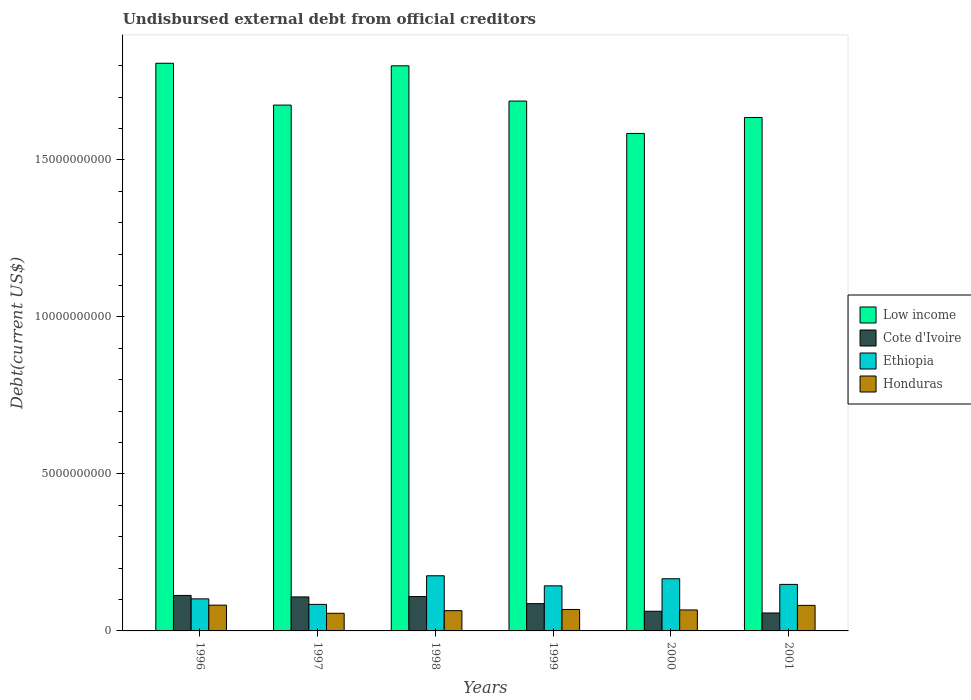How many bars are there on the 2nd tick from the left?
Make the answer very short. 4. How many bars are there on the 2nd tick from the right?
Your response must be concise. 4. What is the label of the 4th group of bars from the left?
Keep it short and to the point. 1999. In how many cases, is the number of bars for a given year not equal to the number of legend labels?
Offer a very short reply. 0. What is the total debt in Ethiopia in 1997?
Your response must be concise. 8.45e+08. Across all years, what is the maximum total debt in Honduras?
Give a very brief answer. 8.21e+08. Across all years, what is the minimum total debt in Cote d'Ivoire?
Give a very brief answer. 5.71e+08. In which year was the total debt in Cote d'Ivoire maximum?
Your answer should be compact. 1996. What is the total total debt in Ethiopia in the graph?
Ensure brevity in your answer.  8.20e+09. What is the difference between the total debt in Ethiopia in 2000 and that in 2001?
Your answer should be compact. 1.80e+08. What is the difference between the total debt in Honduras in 2001 and the total debt in Low income in 1996?
Provide a short and direct response. -1.73e+1. What is the average total debt in Ethiopia per year?
Provide a short and direct response. 1.37e+09. In the year 1999, what is the difference between the total debt in Honduras and total debt in Cote d'Ivoire?
Make the answer very short. -1.86e+08. What is the ratio of the total debt in Low income in 1998 to that in 2001?
Offer a very short reply. 1.1. Is the difference between the total debt in Honduras in 1997 and 1998 greater than the difference between the total debt in Cote d'Ivoire in 1997 and 1998?
Make the answer very short. No. What is the difference between the highest and the second highest total debt in Honduras?
Your answer should be very brief. 6.82e+06. What is the difference between the highest and the lowest total debt in Honduras?
Offer a terse response. 2.59e+08. Is the sum of the total debt in Ethiopia in 1996 and 1999 greater than the maximum total debt in Low income across all years?
Provide a succinct answer. No. What does the 2nd bar from the left in 1997 represents?
Make the answer very short. Cote d'Ivoire. What does the 4th bar from the right in 2001 represents?
Offer a terse response. Low income. Are the values on the major ticks of Y-axis written in scientific E-notation?
Offer a terse response. No. Does the graph contain grids?
Your response must be concise. No. What is the title of the graph?
Offer a very short reply. Undisbursed external debt from official creditors. What is the label or title of the Y-axis?
Give a very brief answer. Debt(current US$). What is the Debt(current US$) in Low income in 1996?
Your response must be concise. 1.81e+1. What is the Debt(current US$) of Cote d'Ivoire in 1996?
Provide a short and direct response. 1.13e+09. What is the Debt(current US$) in Ethiopia in 1996?
Give a very brief answer. 1.02e+09. What is the Debt(current US$) in Honduras in 1996?
Your answer should be very brief. 8.21e+08. What is the Debt(current US$) in Low income in 1997?
Offer a very short reply. 1.67e+1. What is the Debt(current US$) in Cote d'Ivoire in 1997?
Ensure brevity in your answer.  1.08e+09. What is the Debt(current US$) in Ethiopia in 1997?
Keep it short and to the point. 8.45e+08. What is the Debt(current US$) of Honduras in 1997?
Give a very brief answer. 5.62e+08. What is the Debt(current US$) in Low income in 1998?
Offer a terse response. 1.80e+1. What is the Debt(current US$) of Cote d'Ivoire in 1998?
Offer a very short reply. 1.09e+09. What is the Debt(current US$) in Ethiopia in 1998?
Keep it short and to the point. 1.76e+09. What is the Debt(current US$) of Honduras in 1998?
Your response must be concise. 6.46e+08. What is the Debt(current US$) in Low income in 1999?
Ensure brevity in your answer.  1.69e+1. What is the Debt(current US$) in Cote d'Ivoire in 1999?
Ensure brevity in your answer.  8.69e+08. What is the Debt(current US$) in Ethiopia in 1999?
Provide a short and direct response. 1.44e+09. What is the Debt(current US$) in Honduras in 1999?
Make the answer very short. 6.83e+08. What is the Debt(current US$) in Low income in 2000?
Make the answer very short. 1.58e+1. What is the Debt(current US$) of Cote d'Ivoire in 2000?
Your answer should be very brief. 6.26e+08. What is the Debt(current US$) of Ethiopia in 2000?
Offer a terse response. 1.66e+09. What is the Debt(current US$) of Honduras in 2000?
Your answer should be compact. 6.68e+08. What is the Debt(current US$) in Low income in 2001?
Your answer should be compact. 1.64e+1. What is the Debt(current US$) in Cote d'Ivoire in 2001?
Your answer should be compact. 5.71e+08. What is the Debt(current US$) in Ethiopia in 2001?
Your response must be concise. 1.48e+09. What is the Debt(current US$) in Honduras in 2001?
Make the answer very short. 8.14e+08. Across all years, what is the maximum Debt(current US$) in Low income?
Provide a succinct answer. 1.81e+1. Across all years, what is the maximum Debt(current US$) of Cote d'Ivoire?
Your answer should be very brief. 1.13e+09. Across all years, what is the maximum Debt(current US$) of Ethiopia?
Your response must be concise. 1.76e+09. Across all years, what is the maximum Debt(current US$) in Honduras?
Provide a short and direct response. 8.21e+08. Across all years, what is the minimum Debt(current US$) of Low income?
Make the answer very short. 1.58e+1. Across all years, what is the minimum Debt(current US$) in Cote d'Ivoire?
Offer a very short reply. 5.71e+08. Across all years, what is the minimum Debt(current US$) in Ethiopia?
Offer a terse response. 8.45e+08. Across all years, what is the minimum Debt(current US$) of Honduras?
Keep it short and to the point. 5.62e+08. What is the total Debt(current US$) in Low income in the graph?
Make the answer very short. 1.02e+11. What is the total Debt(current US$) in Cote d'Ivoire in the graph?
Provide a short and direct response. 5.37e+09. What is the total Debt(current US$) of Ethiopia in the graph?
Keep it short and to the point. 8.20e+09. What is the total Debt(current US$) of Honduras in the graph?
Provide a succinct answer. 4.19e+09. What is the difference between the Debt(current US$) of Low income in 1996 and that in 1997?
Provide a short and direct response. 1.33e+09. What is the difference between the Debt(current US$) of Cote d'Ivoire in 1996 and that in 1997?
Your answer should be very brief. 4.72e+07. What is the difference between the Debt(current US$) of Ethiopia in 1996 and that in 1997?
Your answer should be very brief. 1.76e+08. What is the difference between the Debt(current US$) in Honduras in 1996 and that in 1997?
Provide a succinct answer. 2.59e+08. What is the difference between the Debt(current US$) in Low income in 1996 and that in 1998?
Give a very brief answer. 8.14e+07. What is the difference between the Debt(current US$) in Cote d'Ivoire in 1996 and that in 1998?
Your answer should be very brief. 3.64e+07. What is the difference between the Debt(current US$) of Ethiopia in 1996 and that in 1998?
Make the answer very short. -7.36e+08. What is the difference between the Debt(current US$) in Honduras in 1996 and that in 1998?
Your answer should be compact. 1.75e+08. What is the difference between the Debt(current US$) of Low income in 1996 and that in 1999?
Provide a short and direct response. 1.20e+09. What is the difference between the Debt(current US$) in Cote d'Ivoire in 1996 and that in 1999?
Your answer should be very brief. 2.61e+08. What is the difference between the Debt(current US$) in Ethiopia in 1996 and that in 1999?
Ensure brevity in your answer.  -4.15e+08. What is the difference between the Debt(current US$) of Honduras in 1996 and that in 1999?
Offer a very short reply. 1.38e+08. What is the difference between the Debt(current US$) in Low income in 1996 and that in 2000?
Provide a succinct answer. 2.24e+09. What is the difference between the Debt(current US$) in Cote d'Ivoire in 1996 and that in 2000?
Keep it short and to the point. 5.04e+08. What is the difference between the Debt(current US$) in Ethiopia in 1996 and that in 2000?
Your answer should be very brief. -6.41e+08. What is the difference between the Debt(current US$) in Honduras in 1996 and that in 2000?
Provide a succinct answer. 1.53e+08. What is the difference between the Debt(current US$) of Low income in 1996 and that in 2001?
Your answer should be compact. 1.73e+09. What is the difference between the Debt(current US$) of Cote d'Ivoire in 1996 and that in 2001?
Provide a succinct answer. 5.59e+08. What is the difference between the Debt(current US$) of Ethiopia in 1996 and that in 2001?
Provide a short and direct response. -4.61e+08. What is the difference between the Debt(current US$) of Honduras in 1996 and that in 2001?
Your answer should be compact. 6.82e+06. What is the difference between the Debt(current US$) in Low income in 1997 and that in 1998?
Keep it short and to the point. -1.25e+09. What is the difference between the Debt(current US$) in Cote d'Ivoire in 1997 and that in 1998?
Give a very brief answer. -1.08e+07. What is the difference between the Debt(current US$) of Ethiopia in 1997 and that in 1998?
Give a very brief answer. -9.11e+08. What is the difference between the Debt(current US$) of Honduras in 1997 and that in 1998?
Offer a terse response. -8.40e+07. What is the difference between the Debt(current US$) of Low income in 1997 and that in 1999?
Provide a succinct answer. -1.28e+08. What is the difference between the Debt(current US$) in Cote d'Ivoire in 1997 and that in 1999?
Your answer should be very brief. 2.14e+08. What is the difference between the Debt(current US$) in Ethiopia in 1997 and that in 1999?
Ensure brevity in your answer.  -5.91e+08. What is the difference between the Debt(current US$) in Honduras in 1997 and that in 1999?
Ensure brevity in your answer.  -1.22e+08. What is the difference between the Debt(current US$) of Low income in 1997 and that in 2000?
Your answer should be compact. 9.03e+08. What is the difference between the Debt(current US$) of Cote d'Ivoire in 1997 and that in 2000?
Provide a short and direct response. 4.57e+08. What is the difference between the Debt(current US$) of Ethiopia in 1997 and that in 2000?
Provide a succinct answer. -8.17e+08. What is the difference between the Debt(current US$) in Honduras in 1997 and that in 2000?
Give a very brief answer. -1.06e+08. What is the difference between the Debt(current US$) of Low income in 1997 and that in 2001?
Your response must be concise. 3.95e+08. What is the difference between the Debt(current US$) of Cote d'Ivoire in 1997 and that in 2001?
Provide a succinct answer. 5.12e+08. What is the difference between the Debt(current US$) in Ethiopia in 1997 and that in 2001?
Your response must be concise. -6.37e+08. What is the difference between the Debt(current US$) of Honduras in 1997 and that in 2001?
Provide a short and direct response. -2.52e+08. What is the difference between the Debt(current US$) in Low income in 1998 and that in 1999?
Your answer should be very brief. 1.12e+09. What is the difference between the Debt(current US$) in Cote d'Ivoire in 1998 and that in 1999?
Your answer should be very brief. 2.25e+08. What is the difference between the Debt(current US$) of Ethiopia in 1998 and that in 1999?
Provide a short and direct response. 3.21e+08. What is the difference between the Debt(current US$) of Honduras in 1998 and that in 1999?
Offer a terse response. -3.75e+07. What is the difference between the Debt(current US$) in Low income in 1998 and that in 2000?
Ensure brevity in your answer.  2.15e+09. What is the difference between the Debt(current US$) of Cote d'Ivoire in 1998 and that in 2000?
Provide a short and direct response. 4.68e+08. What is the difference between the Debt(current US$) in Ethiopia in 1998 and that in 2000?
Make the answer very short. 9.50e+07. What is the difference between the Debt(current US$) of Honduras in 1998 and that in 2000?
Make the answer very short. -2.24e+07. What is the difference between the Debt(current US$) in Low income in 1998 and that in 2001?
Your answer should be compact. 1.65e+09. What is the difference between the Debt(current US$) in Cote d'Ivoire in 1998 and that in 2001?
Offer a very short reply. 5.22e+08. What is the difference between the Debt(current US$) in Ethiopia in 1998 and that in 2001?
Make the answer very short. 2.75e+08. What is the difference between the Debt(current US$) in Honduras in 1998 and that in 2001?
Give a very brief answer. -1.68e+08. What is the difference between the Debt(current US$) of Low income in 1999 and that in 2000?
Make the answer very short. 1.03e+09. What is the difference between the Debt(current US$) in Cote d'Ivoire in 1999 and that in 2000?
Keep it short and to the point. 2.43e+08. What is the difference between the Debt(current US$) in Ethiopia in 1999 and that in 2000?
Offer a very short reply. -2.26e+08. What is the difference between the Debt(current US$) in Honduras in 1999 and that in 2000?
Ensure brevity in your answer.  1.51e+07. What is the difference between the Debt(current US$) of Low income in 1999 and that in 2001?
Provide a short and direct response. 5.23e+08. What is the difference between the Debt(current US$) of Cote d'Ivoire in 1999 and that in 2001?
Your answer should be compact. 2.97e+08. What is the difference between the Debt(current US$) in Ethiopia in 1999 and that in 2001?
Give a very brief answer. -4.62e+07. What is the difference between the Debt(current US$) in Honduras in 1999 and that in 2001?
Ensure brevity in your answer.  -1.31e+08. What is the difference between the Debt(current US$) of Low income in 2000 and that in 2001?
Ensure brevity in your answer.  -5.08e+08. What is the difference between the Debt(current US$) in Cote d'Ivoire in 2000 and that in 2001?
Your answer should be compact. 5.46e+07. What is the difference between the Debt(current US$) in Ethiopia in 2000 and that in 2001?
Provide a short and direct response. 1.80e+08. What is the difference between the Debt(current US$) in Honduras in 2000 and that in 2001?
Offer a very short reply. -1.46e+08. What is the difference between the Debt(current US$) of Low income in 1996 and the Debt(current US$) of Cote d'Ivoire in 1997?
Offer a very short reply. 1.70e+1. What is the difference between the Debt(current US$) in Low income in 1996 and the Debt(current US$) in Ethiopia in 1997?
Your answer should be compact. 1.72e+1. What is the difference between the Debt(current US$) in Low income in 1996 and the Debt(current US$) in Honduras in 1997?
Offer a very short reply. 1.75e+1. What is the difference between the Debt(current US$) in Cote d'Ivoire in 1996 and the Debt(current US$) in Ethiopia in 1997?
Your answer should be compact. 2.85e+08. What is the difference between the Debt(current US$) of Cote d'Ivoire in 1996 and the Debt(current US$) of Honduras in 1997?
Your answer should be compact. 5.69e+08. What is the difference between the Debt(current US$) of Ethiopia in 1996 and the Debt(current US$) of Honduras in 1997?
Provide a succinct answer. 4.59e+08. What is the difference between the Debt(current US$) of Low income in 1996 and the Debt(current US$) of Cote d'Ivoire in 1998?
Offer a terse response. 1.70e+1. What is the difference between the Debt(current US$) of Low income in 1996 and the Debt(current US$) of Ethiopia in 1998?
Keep it short and to the point. 1.63e+1. What is the difference between the Debt(current US$) in Low income in 1996 and the Debt(current US$) in Honduras in 1998?
Ensure brevity in your answer.  1.74e+1. What is the difference between the Debt(current US$) of Cote d'Ivoire in 1996 and the Debt(current US$) of Ethiopia in 1998?
Your response must be concise. -6.26e+08. What is the difference between the Debt(current US$) in Cote d'Ivoire in 1996 and the Debt(current US$) in Honduras in 1998?
Your answer should be compact. 4.84e+08. What is the difference between the Debt(current US$) in Ethiopia in 1996 and the Debt(current US$) in Honduras in 1998?
Ensure brevity in your answer.  3.75e+08. What is the difference between the Debt(current US$) of Low income in 1996 and the Debt(current US$) of Cote d'Ivoire in 1999?
Give a very brief answer. 1.72e+1. What is the difference between the Debt(current US$) in Low income in 1996 and the Debt(current US$) in Ethiopia in 1999?
Keep it short and to the point. 1.66e+1. What is the difference between the Debt(current US$) of Low income in 1996 and the Debt(current US$) of Honduras in 1999?
Offer a terse response. 1.74e+1. What is the difference between the Debt(current US$) in Cote d'Ivoire in 1996 and the Debt(current US$) in Ethiopia in 1999?
Offer a terse response. -3.06e+08. What is the difference between the Debt(current US$) in Cote d'Ivoire in 1996 and the Debt(current US$) in Honduras in 1999?
Make the answer very short. 4.47e+08. What is the difference between the Debt(current US$) in Ethiopia in 1996 and the Debt(current US$) in Honduras in 1999?
Ensure brevity in your answer.  3.38e+08. What is the difference between the Debt(current US$) in Low income in 1996 and the Debt(current US$) in Cote d'Ivoire in 2000?
Provide a short and direct response. 1.75e+1. What is the difference between the Debt(current US$) in Low income in 1996 and the Debt(current US$) in Ethiopia in 2000?
Your response must be concise. 1.64e+1. What is the difference between the Debt(current US$) in Low income in 1996 and the Debt(current US$) in Honduras in 2000?
Provide a short and direct response. 1.74e+1. What is the difference between the Debt(current US$) of Cote d'Ivoire in 1996 and the Debt(current US$) of Ethiopia in 2000?
Provide a succinct answer. -5.31e+08. What is the difference between the Debt(current US$) of Cote d'Ivoire in 1996 and the Debt(current US$) of Honduras in 2000?
Provide a succinct answer. 4.62e+08. What is the difference between the Debt(current US$) in Ethiopia in 1996 and the Debt(current US$) in Honduras in 2000?
Provide a short and direct response. 3.53e+08. What is the difference between the Debt(current US$) in Low income in 1996 and the Debt(current US$) in Cote d'Ivoire in 2001?
Your answer should be compact. 1.75e+1. What is the difference between the Debt(current US$) of Low income in 1996 and the Debt(current US$) of Ethiopia in 2001?
Ensure brevity in your answer.  1.66e+1. What is the difference between the Debt(current US$) in Low income in 1996 and the Debt(current US$) in Honduras in 2001?
Offer a terse response. 1.73e+1. What is the difference between the Debt(current US$) of Cote d'Ivoire in 1996 and the Debt(current US$) of Ethiopia in 2001?
Your answer should be very brief. -3.52e+08. What is the difference between the Debt(current US$) of Cote d'Ivoire in 1996 and the Debt(current US$) of Honduras in 2001?
Offer a terse response. 3.16e+08. What is the difference between the Debt(current US$) of Ethiopia in 1996 and the Debt(current US$) of Honduras in 2001?
Ensure brevity in your answer.  2.07e+08. What is the difference between the Debt(current US$) of Low income in 1997 and the Debt(current US$) of Cote d'Ivoire in 1998?
Your answer should be compact. 1.57e+1. What is the difference between the Debt(current US$) in Low income in 1997 and the Debt(current US$) in Ethiopia in 1998?
Your answer should be very brief. 1.50e+1. What is the difference between the Debt(current US$) of Low income in 1997 and the Debt(current US$) of Honduras in 1998?
Offer a very short reply. 1.61e+1. What is the difference between the Debt(current US$) in Cote d'Ivoire in 1997 and the Debt(current US$) in Ethiopia in 1998?
Provide a short and direct response. -6.74e+08. What is the difference between the Debt(current US$) of Cote d'Ivoire in 1997 and the Debt(current US$) of Honduras in 1998?
Give a very brief answer. 4.37e+08. What is the difference between the Debt(current US$) in Ethiopia in 1997 and the Debt(current US$) in Honduras in 1998?
Your answer should be compact. 1.99e+08. What is the difference between the Debt(current US$) of Low income in 1997 and the Debt(current US$) of Cote d'Ivoire in 1999?
Ensure brevity in your answer.  1.59e+1. What is the difference between the Debt(current US$) in Low income in 1997 and the Debt(current US$) in Ethiopia in 1999?
Your answer should be compact. 1.53e+1. What is the difference between the Debt(current US$) in Low income in 1997 and the Debt(current US$) in Honduras in 1999?
Your answer should be very brief. 1.61e+1. What is the difference between the Debt(current US$) of Cote d'Ivoire in 1997 and the Debt(current US$) of Ethiopia in 1999?
Provide a short and direct response. -3.53e+08. What is the difference between the Debt(current US$) of Cote d'Ivoire in 1997 and the Debt(current US$) of Honduras in 1999?
Give a very brief answer. 4.00e+08. What is the difference between the Debt(current US$) of Ethiopia in 1997 and the Debt(current US$) of Honduras in 1999?
Your answer should be compact. 1.62e+08. What is the difference between the Debt(current US$) in Low income in 1997 and the Debt(current US$) in Cote d'Ivoire in 2000?
Your answer should be compact. 1.61e+1. What is the difference between the Debt(current US$) of Low income in 1997 and the Debt(current US$) of Ethiopia in 2000?
Provide a succinct answer. 1.51e+1. What is the difference between the Debt(current US$) of Low income in 1997 and the Debt(current US$) of Honduras in 2000?
Make the answer very short. 1.61e+1. What is the difference between the Debt(current US$) of Cote d'Ivoire in 1997 and the Debt(current US$) of Ethiopia in 2000?
Give a very brief answer. -5.79e+08. What is the difference between the Debt(current US$) of Cote d'Ivoire in 1997 and the Debt(current US$) of Honduras in 2000?
Offer a terse response. 4.15e+08. What is the difference between the Debt(current US$) in Ethiopia in 1997 and the Debt(current US$) in Honduras in 2000?
Provide a short and direct response. 1.77e+08. What is the difference between the Debt(current US$) of Low income in 1997 and the Debt(current US$) of Cote d'Ivoire in 2001?
Ensure brevity in your answer.  1.62e+1. What is the difference between the Debt(current US$) of Low income in 1997 and the Debt(current US$) of Ethiopia in 2001?
Provide a succinct answer. 1.53e+1. What is the difference between the Debt(current US$) of Low income in 1997 and the Debt(current US$) of Honduras in 2001?
Your response must be concise. 1.59e+1. What is the difference between the Debt(current US$) in Cote d'Ivoire in 1997 and the Debt(current US$) in Ethiopia in 2001?
Provide a short and direct response. -3.99e+08. What is the difference between the Debt(current US$) of Cote d'Ivoire in 1997 and the Debt(current US$) of Honduras in 2001?
Make the answer very short. 2.69e+08. What is the difference between the Debt(current US$) in Ethiopia in 1997 and the Debt(current US$) in Honduras in 2001?
Your response must be concise. 3.10e+07. What is the difference between the Debt(current US$) in Low income in 1998 and the Debt(current US$) in Cote d'Ivoire in 1999?
Provide a short and direct response. 1.71e+1. What is the difference between the Debt(current US$) in Low income in 1998 and the Debt(current US$) in Ethiopia in 1999?
Ensure brevity in your answer.  1.66e+1. What is the difference between the Debt(current US$) of Low income in 1998 and the Debt(current US$) of Honduras in 1999?
Provide a succinct answer. 1.73e+1. What is the difference between the Debt(current US$) of Cote d'Ivoire in 1998 and the Debt(current US$) of Ethiopia in 1999?
Offer a terse response. -3.42e+08. What is the difference between the Debt(current US$) in Cote d'Ivoire in 1998 and the Debt(current US$) in Honduras in 1999?
Your response must be concise. 4.11e+08. What is the difference between the Debt(current US$) in Ethiopia in 1998 and the Debt(current US$) in Honduras in 1999?
Make the answer very short. 1.07e+09. What is the difference between the Debt(current US$) in Low income in 1998 and the Debt(current US$) in Cote d'Ivoire in 2000?
Your response must be concise. 1.74e+1. What is the difference between the Debt(current US$) in Low income in 1998 and the Debt(current US$) in Ethiopia in 2000?
Provide a succinct answer. 1.63e+1. What is the difference between the Debt(current US$) of Low income in 1998 and the Debt(current US$) of Honduras in 2000?
Provide a succinct answer. 1.73e+1. What is the difference between the Debt(current US$) of Cote d'Ivoire in 1998 and the Debt(current US$) of Ethiopia in 2000?
Your answer should be compact. -5.68e+08. What is the difference between the Debt(current US$) of Cote d'Ivoire in 1998 and the Debt(current US$) of Honduras in 2000?
Offer a terse response. 4.26e+08. What is the difference between the Debt(current US$) of Ethiopia in 1998 and the Debt(current US$) of Honduras in 2000?
Offer a terse response. 1.09e+09. What is the difference between the Debt(current US$) in Low income in 1998 and the Debt(current US$) in Cote d'Ivoire in 2001?
Your response must be concise. 1.74e+1. What is the difference between the Debt(current US$) of Low income in 1998 and the Debt(current US$) of Ethiopia in 2001?
Provide a succinct answer. 1.65e+1. What is the difference between the Debt(current US$) in Low income in 1998 and the Debt(current US$) in Honduras in 2001?
Ensure brevity in your answer.  1.72e+1. What is the difference between the Debt(current US$) in Cote d'Ivoire in 1998 and the Debt(current US$) in Ethiopia in 2001?
Give a very brief answer. -3.88e+08. What is the difference between the Debt(current US$) of Cote d'Ivoire in 1998 and the Debt(current US$) of Honduras in 2001?
Your response must be concise. 2.80e+08. What is the difference between the Debt(current US$) of Ethiopia in 1998 and the Debt(current US$) of Honduras in 2001?
Ensure brevity in your answer.  9.43e+08. What is the difference between the Debt(current US$) of Low income in 1999 and the Debt(current US$) of Cote d'Ivoire in 2000?
Make the answer very short. 1.63e+1. What is the difference between the Debt(current US$) in Low income in 1999 and the Debt(current US$) in Ethiopia in 2000?
Your answer should be compact. 1.52e+1. What is the difference between the Debt(current US$) of Low income in 1999 and the Debt(current US$) of Honduras in 2000?
Your answer should be compact. 1.62e+1. What is the difference between the Debt(current US$) in Cote d'Ivoire in 1999 and the Debt(current US$) in Ethiopia in 2000?
Give a very brief answer. -7.93e+08. What is the difference between the Debt(current US$) in Cote d'Ivoire in 1999 and the Debt(current US$) in Honduras in 2000?
Ensure brevity in your answer.  2.01e+08. What is the difference between the Debt(current US$) of Ethiopia in 1999 and the Debt(current US$) of Honduras in 2000?
Ensure brevity in your answer.  7.68e+08. What is the difference between the Debt(current US$) of Low income in 1999 and the Debt(current US$) of Cote d'Ivoire in 2001?
Offer a very short reply. 1.63e+1. What is the difference between the Debt(current US$) in Low income in 1999 and the Debt(current US$) in Ethiopia in 2001?
Your answer should be compact. 1.54e+1. What is the difference between the Debt(current US$) in Low income in 1999 and the Debt(current US$) in Honduras in 2001?
Provide a short and direct response. 1.61e+1. What is the difference between the Debt(current US$) in Cote d'Ivoire in 1999 and the Debt(current US$) in Ethiopia in 2001?
Your answer should be very brief. -6.13e+08. What is the difference between the Debt(current US$) of Cote d'Ivoire in 1999 and the Debt(current US$) of Honduras in 2001?
Ensure brevity in your answer.  5.48e+07. What is the difference between the Debt(current US$) of Ethiopia in 1999 and the Debt(current US$) of Honduras in 2001?
Your response must be concise. 6.22e+08. What is the difference between the Debt(current US$) of Low income in 2000 and the Debt(current US$) of Cote d'Ivoire in 2001?
Offer a terse response. 1.53e+1. What is the difference between the Debt(current US$) of Low income in 2000 and the Debt(current US$) of Ethiopia in 2001?
Make the answer very short. 1.44e+1. What is the difference between the Debt(current US$) of Low income in 2000 and the Debt(current US$) of Honduras in 2001?
Your answer should be very brief. 1.50e+1. What is the difference between the Debt(current US$) of Cote d'Ivoire in 2000 and the Debt(current US$) of Ethiopia in 2001?
Keep it short and to the point. -8.56e+08. What is the difference between the Debt(current US$) in Cote d'Ivoire in 2000 and the Debt(current US$) in Honduras in 2001?
Provide a succinct answer. -1.88e+08. What is the difference between the Debt(current US$) of Ethiopia in 2000 and the Debt(current US$) of Honduras in 2001?
Give a very brief answer. 8.48e+08. What is the average Debt(current US$) of Low income per year?
Offer a very short reply. 1.70e+1. What is the average Debt(current US$) of Cote d'Ivoire per year?
Ensure brevity in your answer.  8.96e+08. What is the average Debt(current US$) of Ethiopia per year?
Provide a succinct answer. 1.37e+09. What is the average Debt(current US$) of Honduras per year?
Give a very brief answer. 6.99e+08. In the year 1996, what is the difference between the Debt(current US$) in Low income and Debt(current US$) in Cote d'Ivoire?
Your answer should be compact. 1.70e+1. In the year 1996, what is the difference between the Debt(current US$) in Low income and Debt(current US$) in Ethiopia?
Your answer should be very brief. 1.71e+1. In the year 1996, what is the difference between the Debt(current US$) of Low income and Debt(current US$) of Honduras?
Ensure brevity in your answer.  1.73e+1. In the year 1996, what is the difference between the Debt(current US$) in Cote d'Ivoire and Debt(current US$) in Ethiopia?
Offer a terse response. 1.09e+08. In the year 1996, what is the difference between the Debt(current US$) in Cote d'Ivoire and Debt(current US$) in Honduras?
Ensure brevity in your answer.  3.09e+08. In the year 1996, what is the difference between the Debt(current US$) of Ethiopia and Debt(current US$) of Honduras?
Ensure brevity in your answer.  2.00e+08. In the year 1997, what is the difference between the Debt(current US$) in Low income and Debt(current US$) in Cote d'Ivoire?
Offer a terse response. 1.57e+1. In the year 1997, what is the difference between the Debt(current US$) in Low income and Debt(current US$) in Ethiopia?
Offer a terse response. 1.59e+1. In the year 1997, what is the difference between the Debt(current US$) in Low income and Debt(current US$) in Honduras?
Provide a short and direct response. 1.62e+1. In the year 1997, what is the difference between the Debt(current US$) in Cote d'Ivoire and Debt(current US$) in Ethiopia?
Provide a succinct answer. 2.38e+08. In the year 1997, what is the difference between the Debt(current US$) of Cote d'Ivoire and Debt(current US$) of Honduras?
Offer a terse response. 5.21e+08. In the year 1997, what is the difference between the Debt(current US$) of Ethiopia and Debt(current US$) of Honduras?
Your answer should be very brief. 2.83e+08. In the year 1998, what is the difference between the Debt(current US$) of Low income and Debt(current US$) of Cote d'Ivoire?
Your answer should be very brief. 1.69e+1. In the year 1998, what is the difference between the Debt(current US$) in Low income and Debt(current US$) in Ethiopia?
Provide a short and direct response. 1.62e+1. In the year 1998, what is the difference between the Debt(current US$) of Low income and Debt(current US$) of Honduras?
Make the answer very short. 1.74e+1. In the year 1998, what is the difference between the Debt(current US$) in Cote d'Ivoire and Debt(current US$) in Ethiopia?
Provide a short and direct response. -6.63e+08. In the year 1998, what is the difference between the Debt(current US$) of Cote d'Ivoire and Debt(current US$) of Honduras?
Keep it short and to the point. 4.48e+08. In the year 1998, what is the difference between the Debt(current US$) in Ethiopia and Debt(current US$) in Honduras?
Offer a very short reply. 1.11e+09. In the year 1999, what is the difference between the Debt(current US$) of Low income and Debt(current US$) of Cote d'Ivoire?
Offer a very short reply. 1.60e+1. In the year 1999, what is the difference between the Debt(current US$) of Low income and Debt(current US$) of Ethiopia?
Ensure brevity in your answer.  1.54e+1. In the year 1999, what is the difference between the Debt(current US$) of Low income and Debt(current US$) of Honduras?
Your response must be concise. 1.62e+1. In the year 1999, what is the difference between the Debt(current US$) of Cote d'Ivoire and Debt(current US$) of Ethiopia?
Your answer should be compact. -5.67e+08. In the year 1999, what is the difference between the Debt(current US$) of Cote d'Ivoire and Debt(current US$) of Honduras?
Offer a very short reply. 1.86e+08. In the year 1999, what is the difference between the Debt(current US$) of Ethiopia and Debt(current US$) of Honduras?
Provide a short and direct response. 7.53e+08. In the year 2000, what is the difference between the Debt(current US$) of Low income and Debt(current US$) of Cote d'Ivoire?
Your response must be concise. 1.52e+1. In the year 2000, what is the difference between the Debt(current US$) in Low income and Debt(current US$) in Ethiopia?
Offer a very short reply. 1.42e+1. In the year 2000, what is the difference between the Debt(current US$) of Low income and Debt(current US$) of Honduras?
Provide a succinct answer. 1.52e+1. In the year 2000, what is the difference between the Debt(current US$) in Cote d'Ivoire and Debt(current US$) in Ethiopia?
Your answer should be compact. -1.04e+09. In the year 2000, what is the difference between the Debt(current US$) in Cote d'Ivoire and Debt(current US$) in Honduras?
Offer a very short reply. -4.21e+07. In the year 2000, what is the difference between the Debt(current US$) of Ethiopia and Debt(current US$) of Honduras?
Your response must be concise. 9.94e+08. In the year 2001, what is the difference between the Debt(current US$) in Low income and Debt(current US$) in Cote d'Ivoire?
Provide a succinct answer. 1.58e+1. In the year 2001, what is the difference between the Debt(current US$) in Low income and Debt(current US$) in Ethiopia?
Keep it short and to the point. 1.49e+1. In the year 2001, what is the difference between the Debt(current US$) in Low income and Debt(current US$) in Honduras?
Keep it short and to the point. 1.55e+1. In the year 2001, what is the difference between the Debt(current US$) in Cote d'Ivoire and Debt(current US$) in Ethiopia?
Your response must be concise. -9.11e+08. In the year 2001, what is the difference between the Debt(current US$) in Cote d'Ivoire and Debt(current US$) in Honduras?
Provide a succinct answer. -2.43e+08. In the year 2001, what is the difference between the Debt(current US$) of Ethiopia and Debt(current US$) of Honduras?
Keep it short and to the point. 6.68e+08. What is the ratio of the Debt(current US$) in Low income in 1996 to that in 1997?
Keep it short and to the point. 1.08. What is the ratio of the Debt(current US$) of Cote d'Ivoire in 1996 to that in 1997?
Keep it short and to the point. 1.04. What is the ratio of the Debt(current US$) in Ethiopia in 1996 to that in 1997?
Offer a terse response. 1.21. What is the ratio of the Debt(current US$) in Honduras in 1996 to that in 1997?
Your answer should be very brief. 1.46. What is the ratio of the Debt(current US$) in Low income in 1996 to that in 1998?
Keep it short and to the point. 1. What is the ratio of the Debt(current US$) of Cote d'Ivoire in 1996 to that in 1998?
Your answer should be very brief. 1.03. What is the ratio of the Debt(current US$) in Ethiopia in 1996 to that in 1998?
Keep it short and to the point. 0.58. What is the ratio of the Debt(current US$) of Honduras in 1996 to that in 1998?
Keep it short and to the point. 1.27. What is the ratio of the Debt(current US$) of Low income in 1996 to that in 1999?
Ensure brevity in your answer.  1.07. What is the ratio of the Debt(current US$) in Cote d'Ivoire in 1996 to that in 1999?
Keep it short and to the point. 1.3. What is the ratio of the Debt(current US$) in Ethiopia in 1996 to that in 1999?
Provide a succinct answer. 0.71. What is the ratio of the Debt(current US$) of Honduras in 1996 to that in 1999?
Offer a terse response. 1.2. What is the ratio of the Debt(current US$) in Low income in 1996 to that in 2000?
Your response must be concise. 1.14. What is the ratio of the Debt(current US$) in Cote d'Ivoire in 1996 to that in 2000?
Offer a very short reply. 1.81. What is the ratio of the Debt(current US$) of Ethiopia in 1996 to that in 2000?
Your response must be concise. 0.61. What is the ratio of the Debt(current US$) of Honduras in 1996 to that in 2000?
Make the answer very short. 1.23. What is the ratio of the Debt(current US$) of Low income in 1996 to that in 2001?
Offer a terse response. 1.11. What is the ratio of the Debt(current US$) in Cote d'Ivoire in 1996 to that in 2001?
Provide a short and direct response. 1.98. What is the ratio of the Debt(current US$) in Ethiopia in 1996 to that in 2001?
Make the answer very short. 0.69. What is the ratio of the Debt(current US$) in Honduras in 1996 to that in 2001?
Make the answer very short. 1.01. What is the ratio of the Debt(current US$) in Low income in 1997 to that in 1998?
Your answer should be very brief. 0.93. What is the ratio of the Debt(current US$) in Cote d'Ivoire in 1997 to that in 1998?
Offer a very short reply. 0.99. What is the ratio of the Debt(current US$) in Ethiopia in 1997 to that in 1998?
Keep it short and to the point. 0.48. What is the ratio of the Debt(current US$) of Honduras in 1997 to that in 1998?
Your answer should be very brief. 0.87. What is the ratio of the Debt(current US$) in Low income in 1997 to that in 1999?
Provide a short and direct response. 0.99. What is the ratio of the Debt(current US$) of Cote d'Ivoire in 1997 to that in 1999?
Give a very brief answer. 1.25. What is the ratio of the Debt(current US$) in Ethiopia in 1997 to that in 1999?
Keep it short and to the point. 0.59. What is the ratio of the Debt(current US$) in Honduras in 1997 to that in 1999?
Your answer should be very brief. 0.82. What is the ratio of the Debt(current US$) in Low income in 1997 to that in 2000?
Your answer should be very brief. 1.06. What is the ratio of the Debt(current US$) in Cote d'Ivoire in 1997 to that in 2000?
Keep it short and to the point. 1.73. What is the ratio of the Debt(current US$) of Ethiopia in 1997 to that in 2000?
Provide a short and direct response. 0.51. What is the ratio of the Debt(current US$) in Honduras in 1997 to that in 2000?
Offer a very short reply. 0.84. What is the ratio of the Debt(current US$) in Low income in 1997 to that in 2001?
Keep it short and to the point. 1.02. What is the ratio of the Debt(current US$) in Cote d'Ivoire in 1997 to that in 2001?
Ensure brevity in your answer.  1.9. What is the ratio of the Debt(current US$) of Ethiopia in 1997 to that in 2001?
Provide a succinct answer. 0.57. What is the ratio of the Debt(current US$) in Honduras in 1997 to that in 2001?
Your response must be concise. 0.69. What is the ratio of the Debt(current US$) in Low income in 1998 to that in 1999?
Offer a very short reply. 1.07. What is the ratio of the Debt(current US$) of Cote d'Ivoire in 1998 to that in 1999?
Your answer should be very brief. 1.26. What is the ratio of the Debt(current US$) of Ethiopia in 1998 to that in 1999?
Your answer should be compact. 1.22. What is the ratio of the Debt(current US$) in Honduras in 1998 to that in 1999?
Your answer should be very brief. 0.95. What is the ratio of the Debt(current US$) in Low income in 1998 to that in 2000?
Keep it short and to the point. 1.14. What is the ratio of the Debt(current US$) of Cote d'Ivoire in 1998 to that in 2000?
Your answer should be very brief. 1.75. What is the ratio of the Debt(current US$) in Ethiopia in 1998 to that in 2000?
Make the answer very short. 1.06. What is the ratio of the Debt(current US$) of Honduras in 1998 to that in 2000?
Your answer should be compact. 0.97. What is the ratio of the Debt(current US$) of Low income in 1998 to that in 2001?
Your answer should be compact. 1.1. What is the ratio of the Debt(current US$) of Cote d'Ivoire in 1998 to that in 2001?
Offer a very short reply. 1.91. What is the ratio of the Debt(current US$) of Ethiopia in 1998 to that in 2001?
Your answer should be compact. 1.19. What is the ratio of the Debt(current US$) of Honduras in 1998 to that in 2001?
Offer a terse response. 0.79. What is the ratio of the Debt(current US$) in Low income in 1999 to that in 2000?
Make the answer very short. 1.07. What is the ratio of the Debt(current US$) of Cote d'Ivoire in 1999 to that in 2000?
Your answer should be compact. 1.39. What is the ratio of the Debt(current US$) of Ethiopia in 1999 to that in 2000?
Your answer should be compact. 0.86. What is the ratio of the Debt(current US$) in Honduras in 1999 to that in 2000?
Make the answer very short. 1.02. What is the ratio of the Debt(current US$) in Low income in 1999 to that in 2001?
Make the answer very short. 1.03. What is the ratio of the Debt(current US$) of Cote d'Ivoire in 1999 to that in 2001?
Make the answer very short. 1.52. What is the ratio of the Debt(current US$) in Ethiopia in 1999 to that in 2001?
Your answer should be compact. 0.97. What is the ratio of the Debt(current US$) of Honduras in 1999 to that in 2001?
Ensure brevity in your answer.  0.84. What is the ratio of the Debt(current US$) in Low income in 2000 to that in 2001?
Provide a succinct answer. 0.97. What is the ratio of the Debt(current US$) of Cote d'Ivoire in 2000 to that in 2001?
Ensure brevity in your answer.  1.1. What is the ratio of the Debt(current US$) of Ethiopia in 2000 to that in 2001?
Ensure brevity in your answer.  1.12. What is the ratio of the Debt(current US$) of Honduras in 2000 to that in 2001?
Offer a very short reply. 0.82. What is the difference between the highest and the second highest Debt(current US$) in Low income?
Your response must be concise. 8.14e+07. What is the difference between the highest and the second highest Debt(current US$) of Cote d'Ivoire?
Your answer should be very brief. 3.64e+07. What is the difference between the highest and the second highest Debt(current US$) in Ethiopia?
Provide a short and direct response. 9.50e+07. What is the difference between the highest and the second highest Debt(current US$) in Honduras?
Your answer should be very brief. 6.82e+06. What is the difference between the highest and the lowest Debt(current US$) in Low income?
Give a very brief answer. 2.24e+09. What is the difference between the highest and the lowest Debt(current US$) of Cote d'Ivoire?
Keep it short and to the point. 5.59e+08. What is the difference between the highest and the lowest Debt(current US$) in Ethiopia?
Provide a succinct answer. 9.11e+08. What is the difference between the highest and the lowest Debt(current US$) in Honduras?
Your answer should be compact. 2.59e+08. 